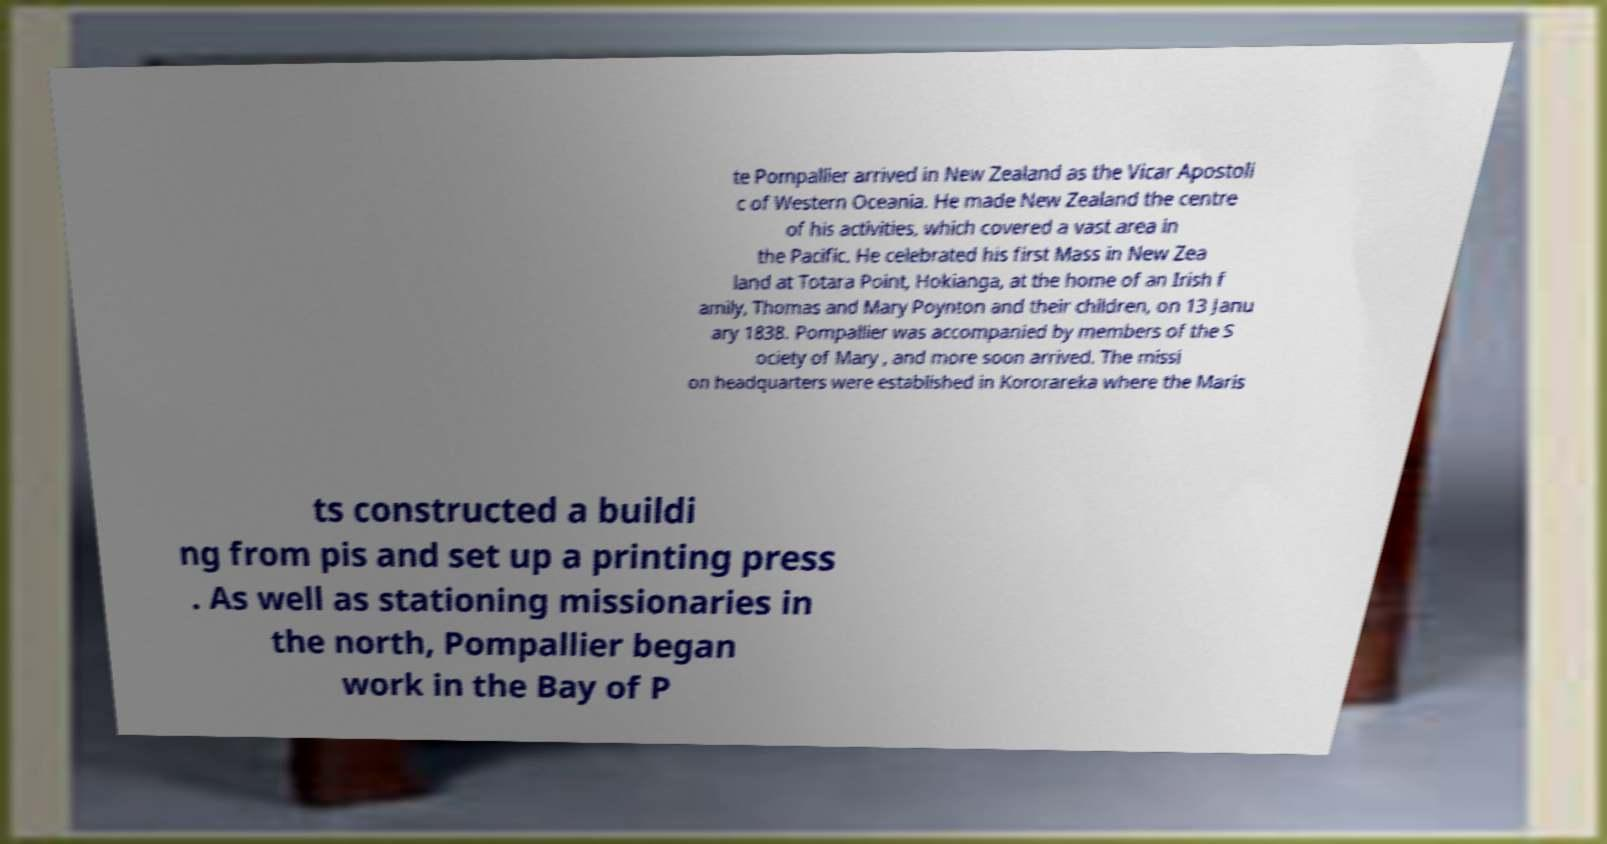What messages or text are displayed in this image? I need them in a readable, typed format. te Pompallier arrived in New Zealand as the Vicar Apostoli c of Western Oceania. He made New Zealand the centre of his activities, which covered a vast area in the Pacific. He celebrated his first Mass in New Zea land at Totara Point, Hokianga, at the home of an Irish f amily, Thomas and Mary Poynton and their children, on 13 Janu ary 1838. Pompallier was accompanied by members of the S ociety of Mary , and more soon arrived. The missi on headquarters were established in Kororareka where the Maris ts constructed a buildi ng from pis and set up a printing press . As well as stationing missionaries in the north, Pompallier began work in the Bay of P 